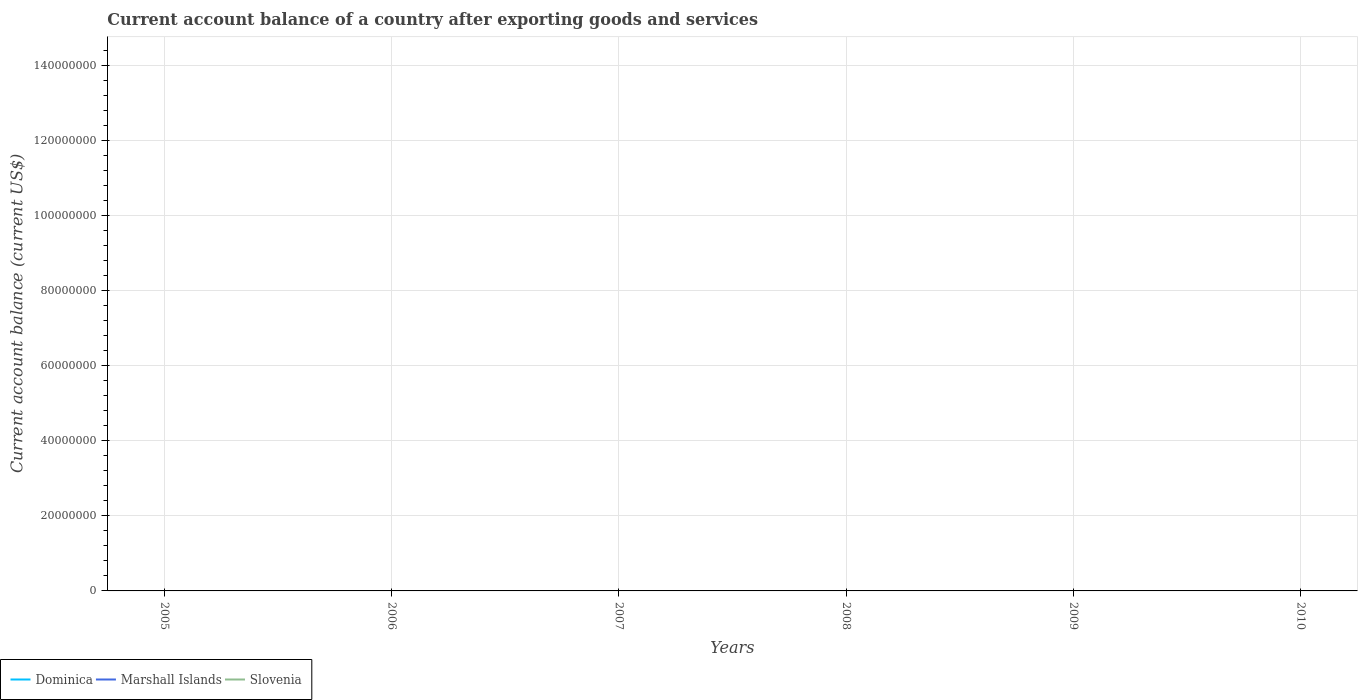How many different coloured lines are there?
Make the answer very short. 0. Does the line corresponding to Marshall Islands intersect with the line corresponding to Dominica?
Keep it short and to the point. No. Is the number of lines equal to the number of legend labels?
Keep it short and to the point. No. Across all years, what is the maximum account balance in Dominica?
Provide a succinct answer. 0. Is the account balance in Marshall Islands strictly greater than the account balance in Slovenia over the years?
Provide a succinct answer. No. How many lines are there?
Give a very brief answer. 0. How many years are there in the graph?
Your response must be concise. 6. Does the graph contain grids?
Your answer should be compact. Yes. Where does the legend appear in the graph?
Ensure brevity in your answer.  Bottom left. What is the title of the graph?
Keep it short and to the point. Current account balance of a country after exporting goods and services. What is the label or title of the X-axis?
Your response must be concise. Years. What is the label or title of the Y-axis?
Ensure brevity in your answer.  Current account balance (current US$). What is the Current account balance (current US$) in Dominica in 2006?
Your answer should be very brief. 0. What is the Current account balance (current US$) in Marshall Islands in 2006?
Ensure brevity in your answer.  0. What is the Current account balance (current US$) in Slovenia in 2006?
Your response must be concise. 0. What is the Current account balance (current US$) of Marshall Islands in 2007?
Provide a succinct answer. 0. What is the Current account balance (current US$) in Dominica in 2008?
Your answer should be compact. 0. What is the Current account balance (current US$) of Marshall Islands in 2008?
Ensure brevity in your answer.  0. What is the Current account balance (current US$) of Marshall Islands in 2009?
Ensure brevity in your answer.  0. What is the Current account balance (current US$) of Slovenia in 2009?
Give a very brief answer. 0. What is the Current account balance (current US$) of Dominica in 2010?
Provide a short and direct response. 0. What is the Current account balance (current US$) in Marshall Islands in 2010?
Your answer should be compact. 0. What is the Current account balance (current US$) in Slovenia in 2010?
Offer a very short reply. 0. What is the total Current account balance (current US$) of Dominica in the graph?
Your answer should be compact. 0. What is the total Current account balance (current US$) of Slovenia in the graph?
Your answer should be compact. 0. What is the average Current account balance (current US$) of Slovenia per year?
Ensure brevity in your answer.  0. 